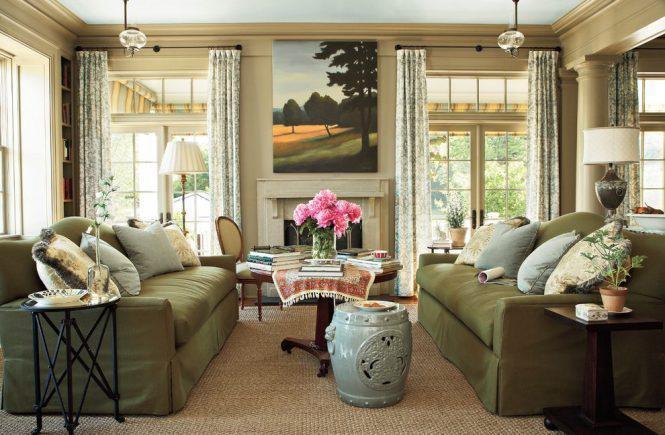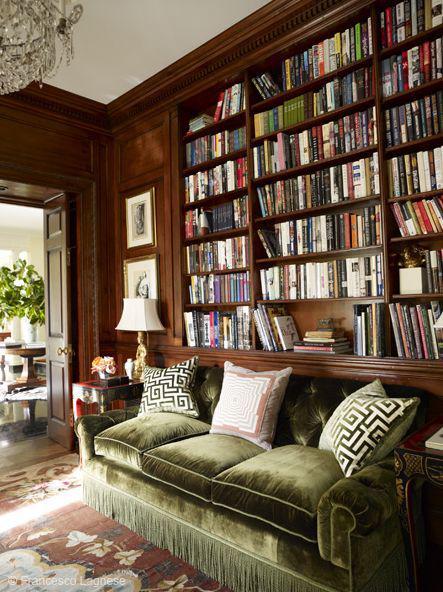The first image is the image on the left, the second image is the image on the right. For the images displayed, is the sentence "In at least one image there is a green wall with at least two framed pictures." factually correct? Answer yes or no. No. The first image is the image on the left, the second image is the image on the right. Given the left and right images, does the statement "The left image shows framed pictures on the front of green bookshelves in front of a green wall, and a brown sofa in front of the bookshelves." hold true? Answer yes or no. No. 